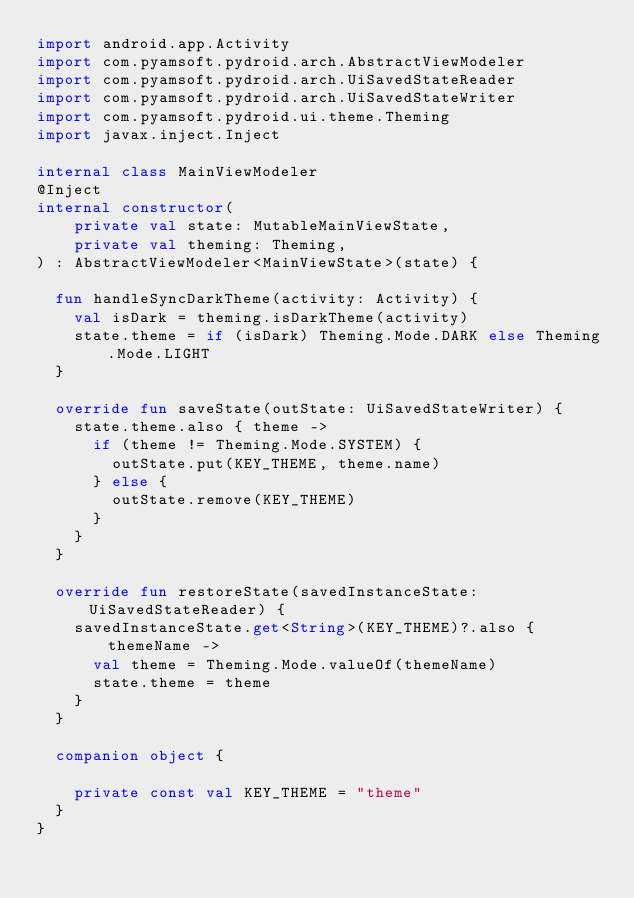<code> <loc_0><loc_0><loc_500><loc_500><_Kotlin_>import android.app.Activity
import com.pyamsoft.pydroid.arch.AbstractViewModeler
import com.pyamsoft.pydroid.arch.UiSavedStateReader
import com.pyamsoft.pydroid.arch.UiSavedStateWriter
import com.pyamsoft.pydroid.ui.theme.Theming
import javax.inject.Inject

internal class MainViewModeler
@Inject
internal constructor(
    private val state: MutableMainViewState,
    private val theming: Theming,
) : AbstractViewModeler<MainViewState>(state) {

  fun handleSyncDarkTheme(activity: Activity) {
    val isDark = theming.isDarkTheme(activity)
    state.theme = if (isDark) Theming.Mode.DARK else Theming.Mode.LIGHT
  }

  override fun saveState(outState: UiSavedStateWriter) {
    state.theme.also { theme ->
      if (theme != Theming.Mode.SYSTEM) {
        outState.put(KEY_THEME, theme.name)
      } else {
        outState.remove(KEY_THEME)
      }
    }
  }

  override fun restoreState(savedInstanceState: UiSavedStateReader) {
    savedInstanceState.get<String>(KEY_THEME)?.also { themeName ->
      val theme = Theming.Mode.valueOf(themeName)
      state.theme = theme
    }
  }

  companion object {

    private const val KEY_THEME = "theme"
  }
}
</code> 